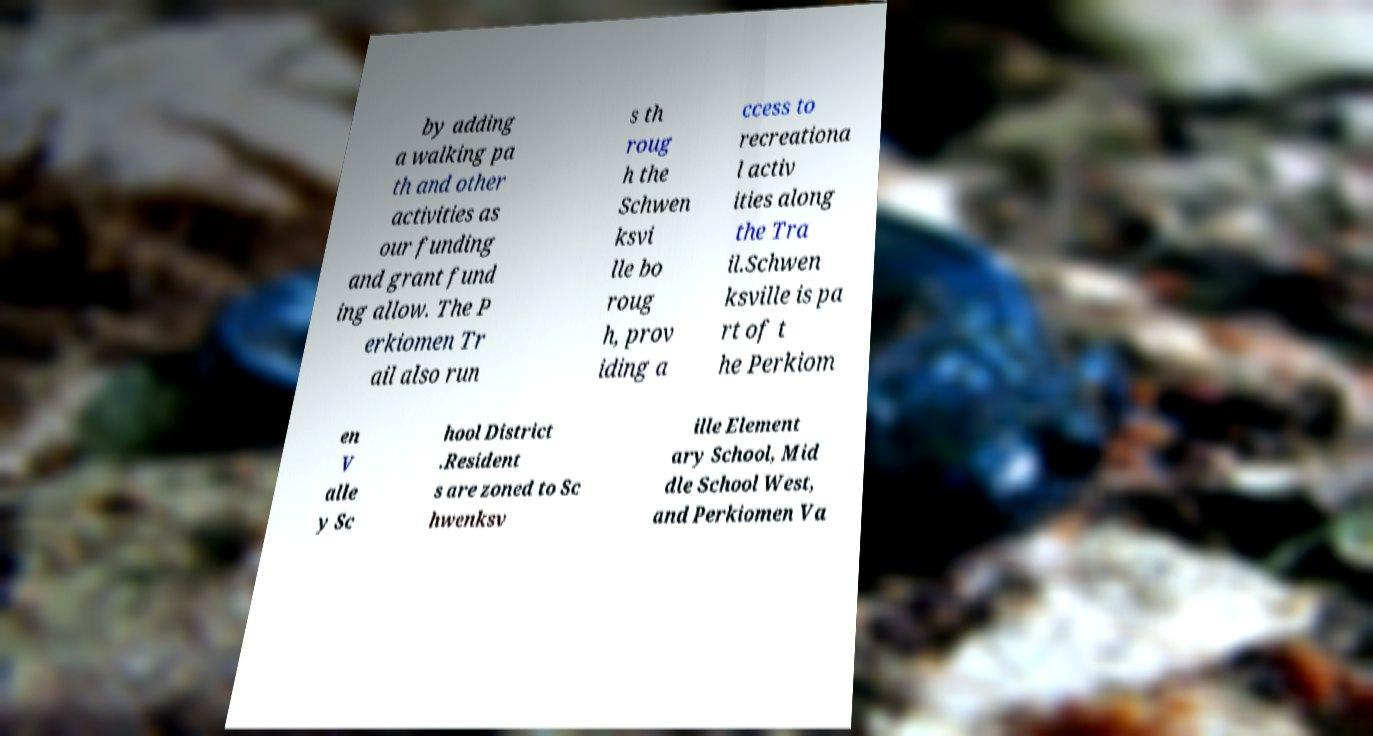Can you accurately transcribe the text from the provided image for me? by adding a walking pa th and other activities as our funding and grant fund ing allow. The P erkiomen Tr ail also run s th roug h the Schwen ksvi lle bo roug h, prov iding a ccess to recreationa l activ ities along the Tra il.Schwen ksville is pa rt of t he Perkiom en V alle y Sc hool District .Resident s are zoned to Sc hwenksv ille Element ary School, Mid dle School West, and Perkiomen Va 